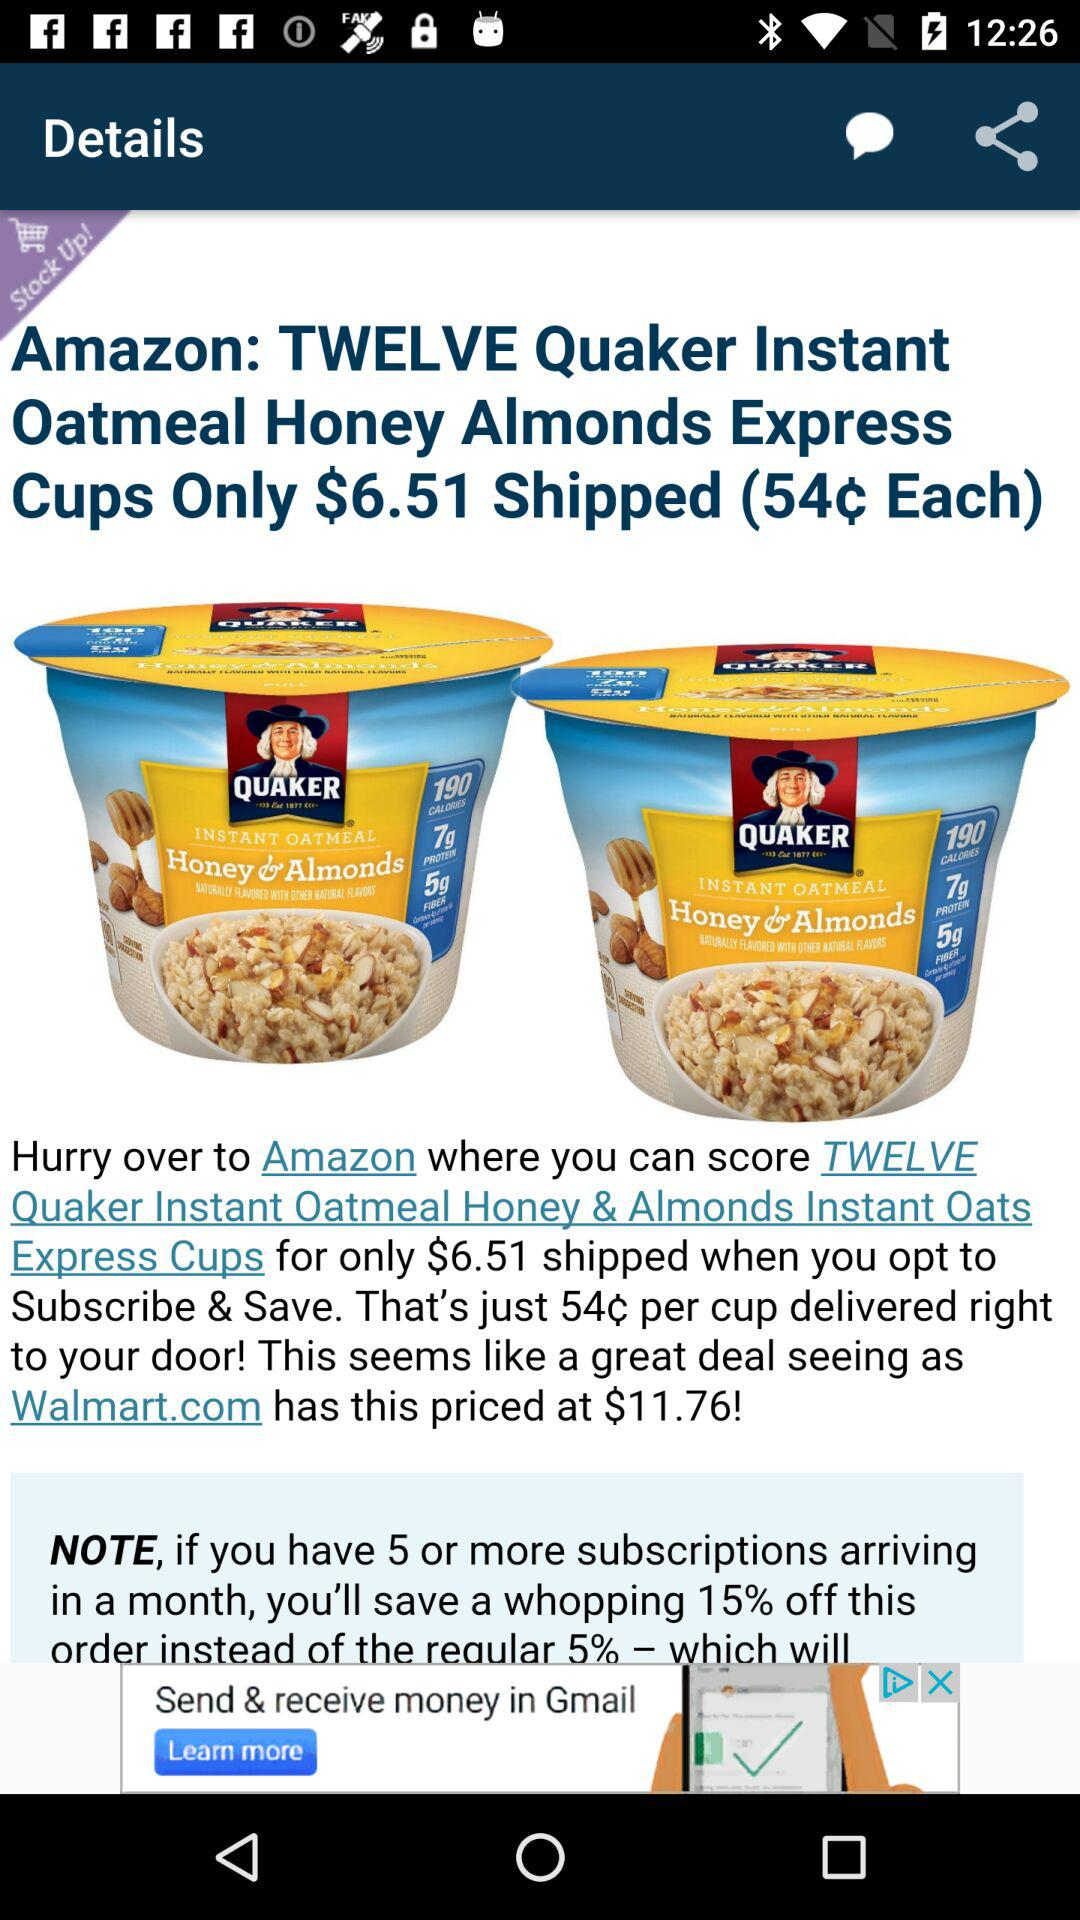How much more is the price on Walmart.com than the price on Amazon?
Answer the question using a single word or phrase. $5.25 